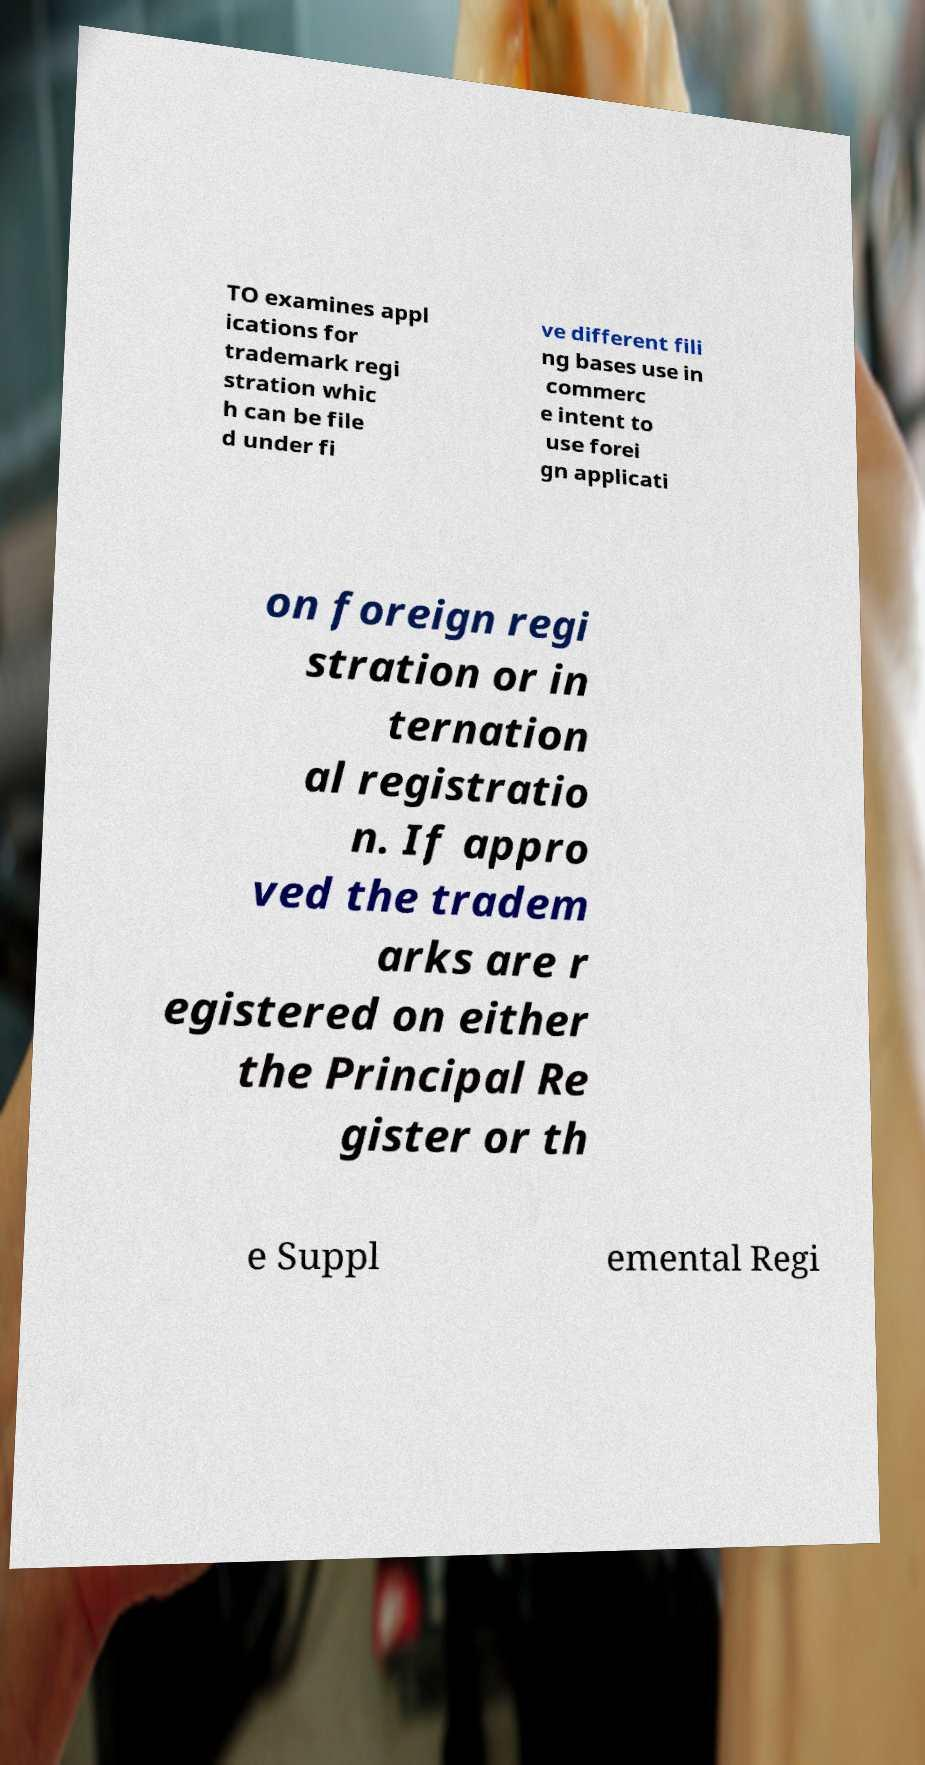Could you assist in decoding the text presented in this image and type it out clearly? TO examines appl ications for trademark regi stration whic h can be file d under fi ve different fili ng bases use in commerc e intent to use forei gn applicati on foreign regi stration or in ternation al registratio n. If appro ved the tradem arks are r egistered on either the Principal Re gister or th e Suppl emental Regi 